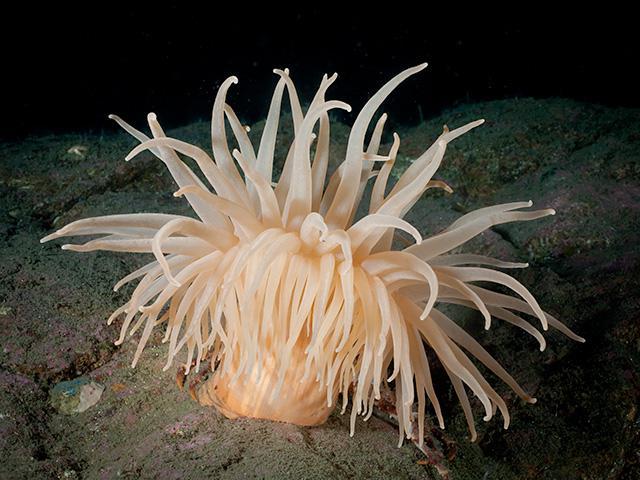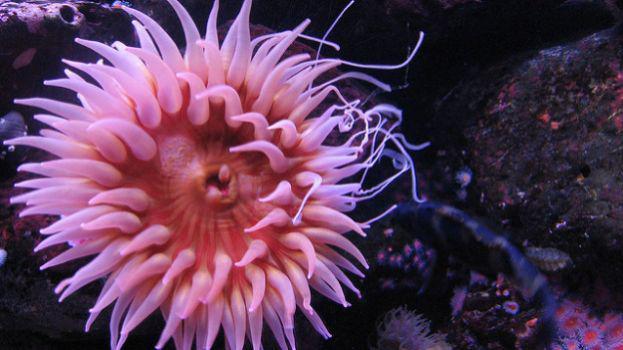The first image is the image on the left, the second image is the image on the right. Evaluate the accuracy of this statement regarding the images: "A flower-shaped anemone has solid-colored, tapered, pinkish-lavender tendrils, with no fish swimming among them.". Is it true? Answer yes or no. Yes. The first image is the image on the left, the second image is the image on the right. Assess this claim about the two images: "A sea anemone is a solid color pink and there are no fish swimming around it.". Correct or not? Answer yes or no. Yes. 